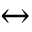Convert formula to latex. <formula><loc_0><loc_0><loc_500><loc_500>\leftrightarrow</formula> 